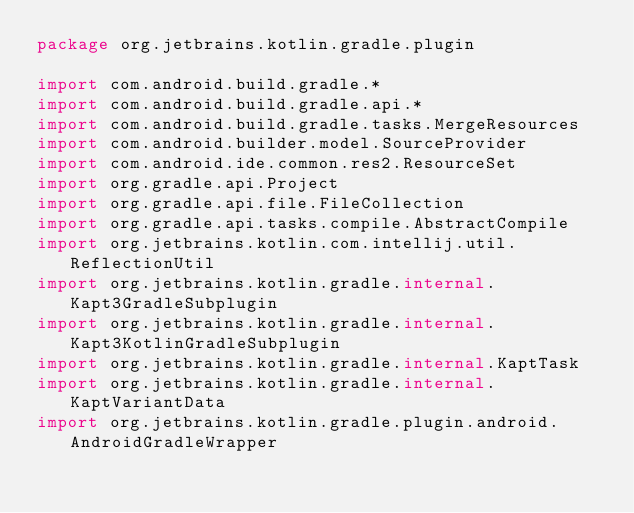<code> <loc_0><loc_0><loc_500><loc_500><_Kotlin_>package org.jetbrains.kotlin.gradle.plugin

import com.android.build.gradle.*
import com.android.build.gradle.api.*
import com.android.build.gradle.tasks.MergeResources
import com.android.builder.model.SourceProvider
import com.android.ide.common.res2.ResourceSet
import org.gradle.api.Project
import org.gradle.api.file.FileCollection
import org.gradle.api.tasks.compile.AbstractCompile
import org.jetbrains.kotlin.com.intellij.util.ReflectionUtil
import org.jetbrains.kotlin.gradle.internal.Kapt3GradleSubplugin
import org.jetbrains.kotlin.gradle.internal.Kapt3KotlinGradleSubplugin
import org.jetbrains.kotlin.gradle.internal.KaptTask
import org.jetbrains.kotlin.gradle.internal.KaptVariantData
import org.jetbrains.kotlin.gradle.plugin.android.AndroidGradleWrapper</code> 